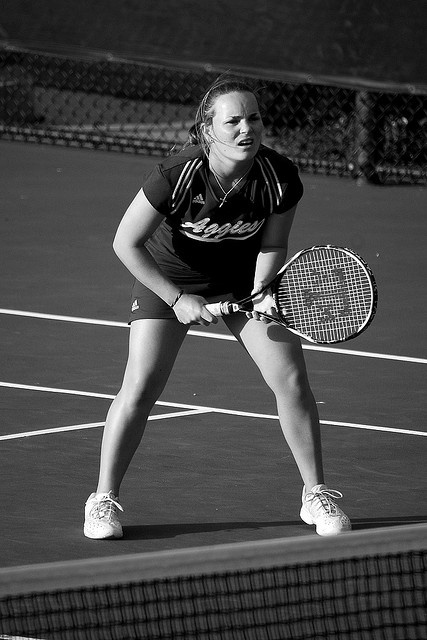Describe the objects in this image and their specific colors. I can see people in black, lightgray, gray, and darkgray tones and tennis racket in black, gray, lightgray, and darkgray tones in this image. 